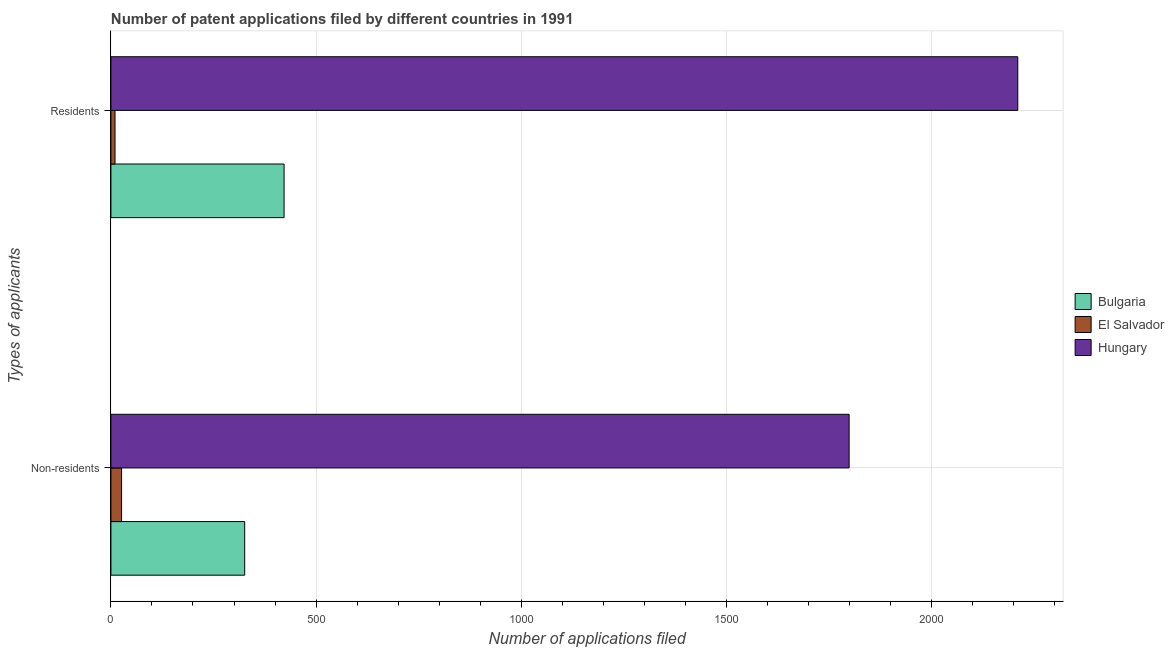How many groups of bars are there?
Offer a terse response. 2. Are the number of bars per tick equal to the number of legend labels?
Your answer should be very brief. Yes. How many bars are there on the 2nd tick from the bottom?
Offer a very short reply. 3. What is the label of the 2nd group of bars from the top?
Your response must be concise. Non-residents. What is the number of patent applications by non residents in Bulgaria?
Your answer should be compact. 326. Across all countries, what is the maximum number of patent applications by residents?
Make the answer very short. 2210. Across all countries, what is the minimum number of patent applications by non residents?
Provide a short and direct response. 26. In which country was the number of patent applications by residents maximum?
Ensure brevity in your answer.  Hungary. In which country was the number of patent applications by non residents minimum?
Offer a terse response. El Salvador. What is the total number of patent applications by non residents in the graph?
Your answer should be very brief. 2151. What is the difference between the number of patent applications by non residents in Bulgaria and that in Hungary?
Give a very brief answer. -1473. What is the difference between the number of patent applications by non residents in El Salvador and the number of patent applications by residents in Bulgaria?
Your answer should be very brief. -396. What is the average number of patent applications by non residents per country?
Offer a very short reply. 717. What is the difference between the number of patent applications by residents and number of patent applications by non residents in Hungary?
Keep it short and to the point. 411. What is the ratio of the number of patent applications by residents in El Salvador to that in Bulgaria?
Give a very brief answer. 0.02. Is the number of patent applications by residents in Hungary less than that in El Salvador?
Offer a terse response. No. What does the 3rd bar from the top in Residents represents?
Offer a very short reply. Bulgaria. What does the 1st bar from the bottom in Residents represents?
Give a very brief answer. Bulgaria. How many bars are there?
Your answer should be very brief. 6. Are all the bars in the graph horizontal?
Your answer should be compact. Yes. What is the difference between two consecutive major ticks on the X-axis?
Your answer should be compact. 500. Does the graph contain any zero values?
Provide a succinct answer. No. How are the legend labels stacked?
Your answer should be compact. Vertical. What is the title of the graph?
Offer a very short reply. Number of patent applications filed by different countries in 1991. What is the label or title of the X-axis?
Your answer should be very brief. Number of applications filed. What is the label or title of the Y-axis?
Your answer should be compact. Types of applicants. What is the Number of applications filed of Bulgaria in Non-residents?
Give a very brief answer. 326. What is the Number of applications filed in El Salvador in Non-residents?
Your response must be concise. 26. What is the Number of applications filed in Hungary in Non-residents?
Make the answer very short. 1799. What is the Number of applications filed in Bulgaria in Residents?
Keep it short and to the point. 422. What is the Number of applications filed of El Salvador in Residents?
Make the answer very short. 10. What is the Number of applications filed in Hungary in Residents?
Your response must be concise. 2210. Across all Types of applicants, what is the maximum Number of applications filed in Bulgaria?
Your answer should be very brief. 422. Across all Types of applicants, what is the maximum Number of applications filed in El Salvador?
Offer a terse response. 26. Across all Types of applicants, what is the maximum Number of applications filed in Hungary?
Ensure brevity in your answer.  2210. Across all Types of applicants, what is the minimum Number of applications filed in Bulgaria?
Offer a very short reply. 326. Across all Types of applicants, what is the minimum Number of applications filed in Hungary?
Your answer should be very brief. 1799. What is the total Number of applications filed of Bulgaria in the graph?
Ensure brevity in your answer.  748. What is the total Number of applications filed of El Salvador in the graph?
Your answer should be compact. 36. What is the total Number of applications filed of Hungary in the graph?
Provide a succinct answer. 4009. What is the difference between the Number of applications filed of Bulgaria in Non-residents and that in Residents?
Provide a short and direct response. -96. What is the difference between the Number of applications filed of Hungary in Non-residents and that in Residents?
Provide a short and direct response. -411. What is the difference between the Number of applications filed of Bulgaria in Non-residents and the Number of applications filed of El Salvador in Residents?
Provide a short and direct response. 316. What is the difference between the Number of applications filed of Bulgaria in Non-residents and the Number of applications filed of Hungary in Residents?
Your answer should be compact. -1884. What is the difference between the Number of applications filed of El Salvador in Non-residents and the Number of applications filed of Hungary in Residents?
Give a very brief answer. -2184. What is the average Number of applications filed in Bulgaria per Types of applicants?
Make the answer very short. 374. What is the average Number of applications filed of El Salvador per Types of applicants?
Offer a very short reply. 18. What is the average Number of applications filed in Hungary per Types of applicants?
Your answer should be very brief. 2004.5. What is the difference between the Number of applications filed in Bulgaria and Number of applications filed in El Salvador in Non-residents?
Offer a very short reply. 300. What is the difference between the Number of applications filed of Bulgaria and Number of applications filed of Hungary in Non-residents?
Offer a terse response. -1473. What is the difference between the Number of applications filed in El Salvador and Number of applications filed in Hungary in Non-residents?
Provide a succinct answer. -1773. What is the difference between the Number of applications filed in Bulgaria and Number of applications filed in El Salvador in Residents?
Provide a short and direct response. 412. What is the difference between the Number of applications filed of Bulgaria and Number of applications filed of Hungary in Residents?
Your answer should be compact. -1788. What is the difference between the Number of applications filed of El Salvador and Number of applications filed of Hungary in Residents?
Keep it short and to the point. -2200. What is the ratio of the Number of applications filed of Bulgaria in Non-residents to that in Residents?
Offer a very short reply. 0.77. What is the ratio of the Number of applications filed of Hungary in Non-residents to that in Residents?
Provide a succinct answer. 0.81. What is the difference between the highest and the second highest Number of applications filed of Bulgaria?
Your response must be concise. 96. What is the difference between the highest and the second highest Number of applications filed in Hungary?
Your answer should be compact. 411. What is the difference between the highest and the lowest Number of applications filed of Bulgaria?
Make the answer very short. 96. What is the difference between the highest and the lowest Number of applications filed in Hungary?
Provide a short and direct response. 411. 